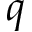<formula> <loc_0><loc_0><loc_500><loc_500>q</formula> 